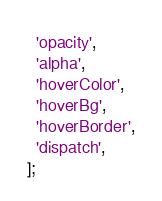<code> <loc_0><loc_0><loc_500><loc_500><_JavaScript_>  'opacity',
  'alpha',
  'hoverColor',
  'hoverBg',
  'hoverBorder',
  'dispatch',
];
</code> 